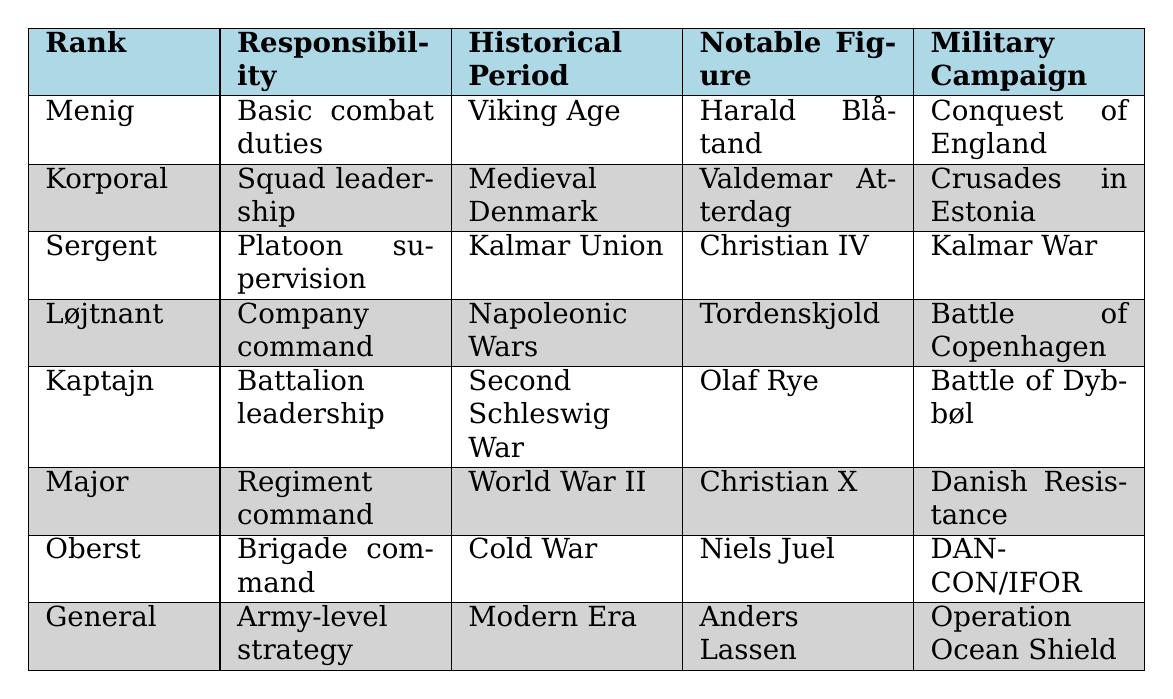What is the responsibility associated with the rank of 'Kaptajn'? According to the table, the rank 'Kaptajn' has the responsibility of 'Battalion leadership'.
Answer: Battalion leadership Who is the notable figure during the 'Cold War'? The table indicates that the notable figure during the 'Cold War' is 'Niels Juel'.
Answer: Niels Juel Does the rank of 'General' correspond to 'Platoon supervision'? By consulting the table, the 'General' rank has the responsibility of 'Army-level strategy', not 'Platoon supervision'.
Answer: No Which rank is responsible for 'Company command' and in which historical period? The table shows that the rank responsible for 'Company command' is 'Løjtnant' during the 'Napoleonic Wars'.
Answer: Løjtnant, Napoleonic Wars What is the main military campaign associated with 'Christian IV'? The table lists that 'Christian IV' was notable during the 'Kalmar Union' and is associated with the 'Kalmar War'.
Answer: Kalmar War Which historical period saw the rank of 'Major'? The table indicates that the rank of 'Major' belongs to the 'World War II' historical period.
Answer: World War II How many ranks have responsibilities that include leadership roles? Upon reviewing the table, the ranks with leadership responsibilities are: Korporal, Sergent, Kaptajn, Major, Oberst, and General, totaling six ranks.
Answer: Six ranks Which rank has the highest level of responsibility based on the table? according to the table, 'General' has the highest level of responsibility which is 'Army-level strategy'.
Answer: General During which historical period did the 'Battle of Dybbøl' take place, and what was the corresponding rank? The table states that the 'Battle of Dybbøl' took place during the 'Second Schleswig War' and it corresponds with the rank of 'Kaptajn'.
Answer: Second Schleswig War, Kaptajn What notable figure led during the 'Danish Resistance'? The table identifies 'Christian X' as the notable figure during the 'Danish Resistance'.
Answer: Christian X 